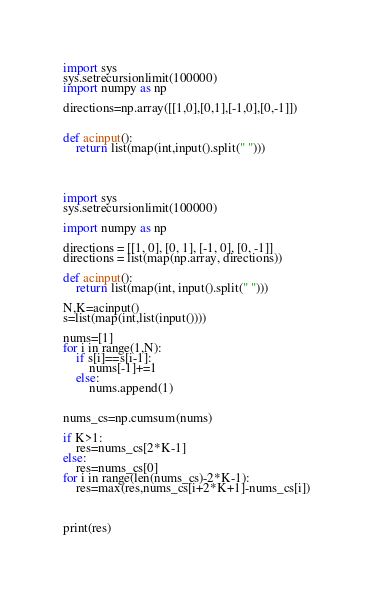Convert code to text. <code><loc_0><loc_0><loc_500><loc_500><_Python_>
import sys
sys.setrecursionlimit(100000)
import numpy as np

directions=np.array([[1,0],[0,1],[-1,0],[0,-1]])


def acinput():
    return list(map(int,input().split(" ")))




import sys
sys.setrecursionlimit(100000)

import numpy as np

directions = [[1, 0], [0, 1], [-1, 0], [0, -1]]
directions = list(map(np.array, directions))

def acinput():
    return list(map(int, input().split(" ")))

N,K=acinput()
s=list(map(int,list(input())))

nums=[1]
for i in range(1,N):
    if s[i]==s[i-1]:
        nums[-1]+=1
    else:
        nums.append(1)


nums_cs=np.cumsum(nums)

if K>1:
    res=nums_cs[2*K-1]
else:
    res=nums_cs[0]
for i in range(len(nums_cs)-2*K-1):
    res=max(res,nums_cs[i+2*K+1]-nums_cs[i])



print(res)
</code> 